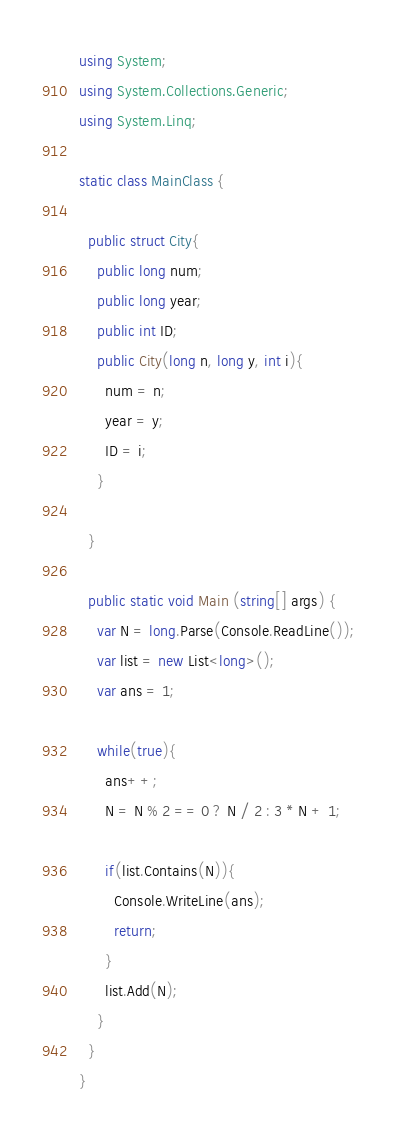<code> <loc_0><loc_0><loc_500><loc_500><_C#_>using System;
using System.Collections.Generic;
using System.Linq;
 
static class MainClass {
 
  public struct City{
    public long num;
    public long year;
    public int ID;
    public City(long n, long y, int i){
      num = n;
      year = y;
      ID = i;
    }
 
  }
 
  public static void Main (string[] args) {
    var N = long.Parse(Console.ReadLine());
    var list = new List<long>();
    var ans = 1;
 
    while(true){
      ans++;
      N = N % 2 == 0 ? N / 2 : 3 * N + 1;

      if(list.Contains(N)){
        Console.WriteLine(ans);
        return;
      }
      list.Add(N);
    }
  }
}</code> 